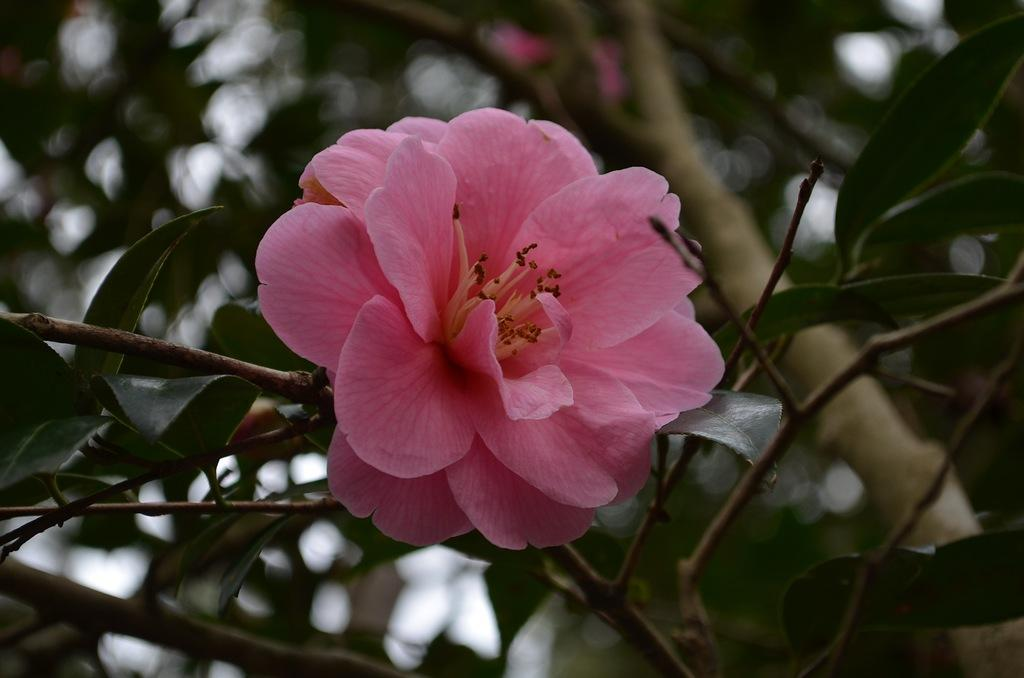What is the main subject of the picture? There is a flower in the picture. What can be seen in the background of the picture? There are tree branches and leaves in the background of the picture. What type of cap is the flower wearing in the image? There is no cap present in the image, as flowers do not wear caps. Can you see a boat in the background of the image? There is no boat present in the image; the background features tree branches and leaves. 